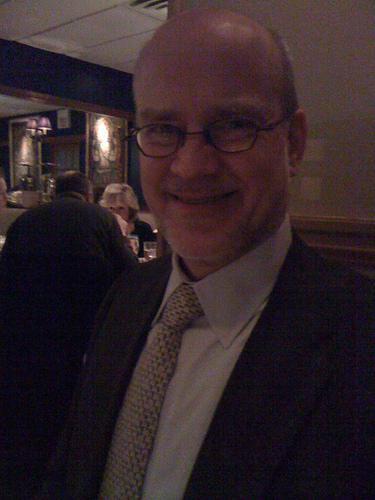How many eyes does he have?
Give a very brief answer. 2. 